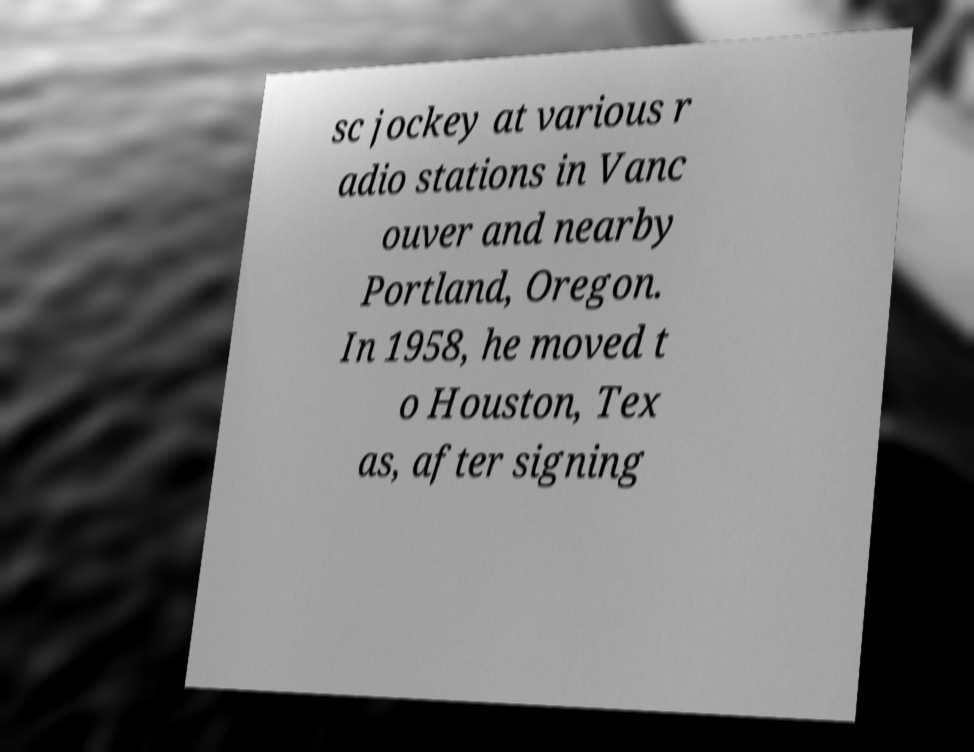Please identify and transcribe the text found in this image. sc jockey at various r adio stations in Vanc ouver and nearby Portland, Oregon. In 1958, he moved t o Houston, Tex as, after signing 